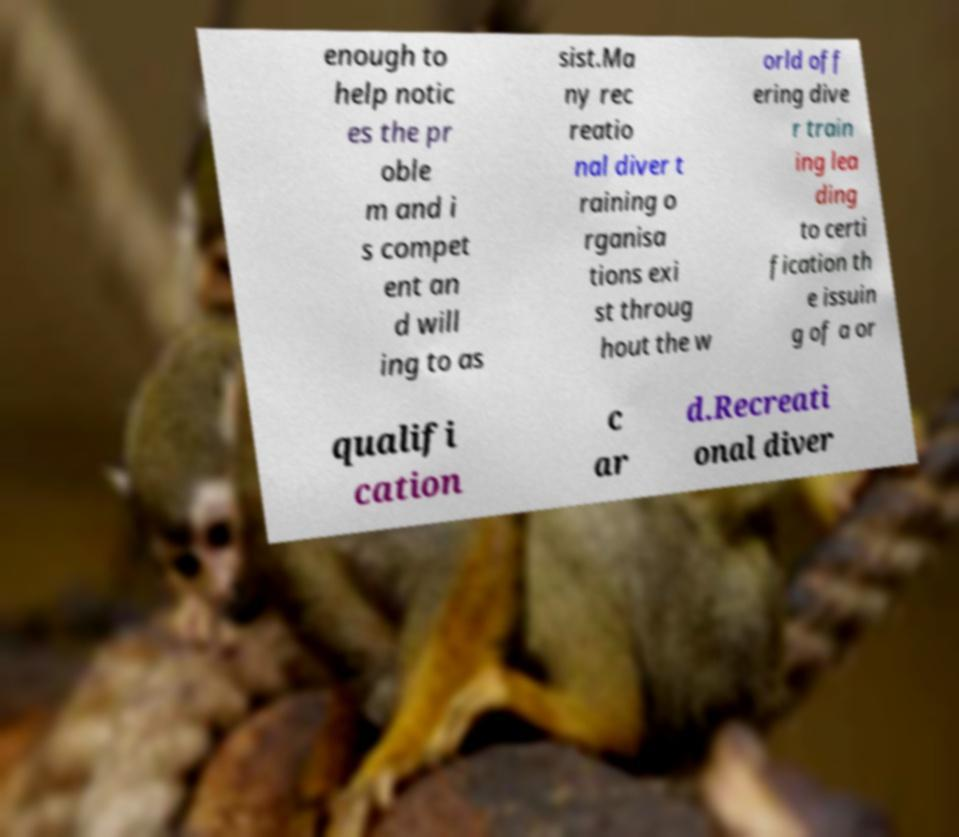I need the written content from this picture converted into text. Can you do that? enough to help notic es the pr oble m and i s compet ent an d will ing to as sist.Ma ny rec reatio nal diver t raining o rganisa tions exi st throug hout the w orld off ering dive r train ing lea ding to certi fication th e issuin g of a or qualifi cation c ar d.Recreati onal diver 